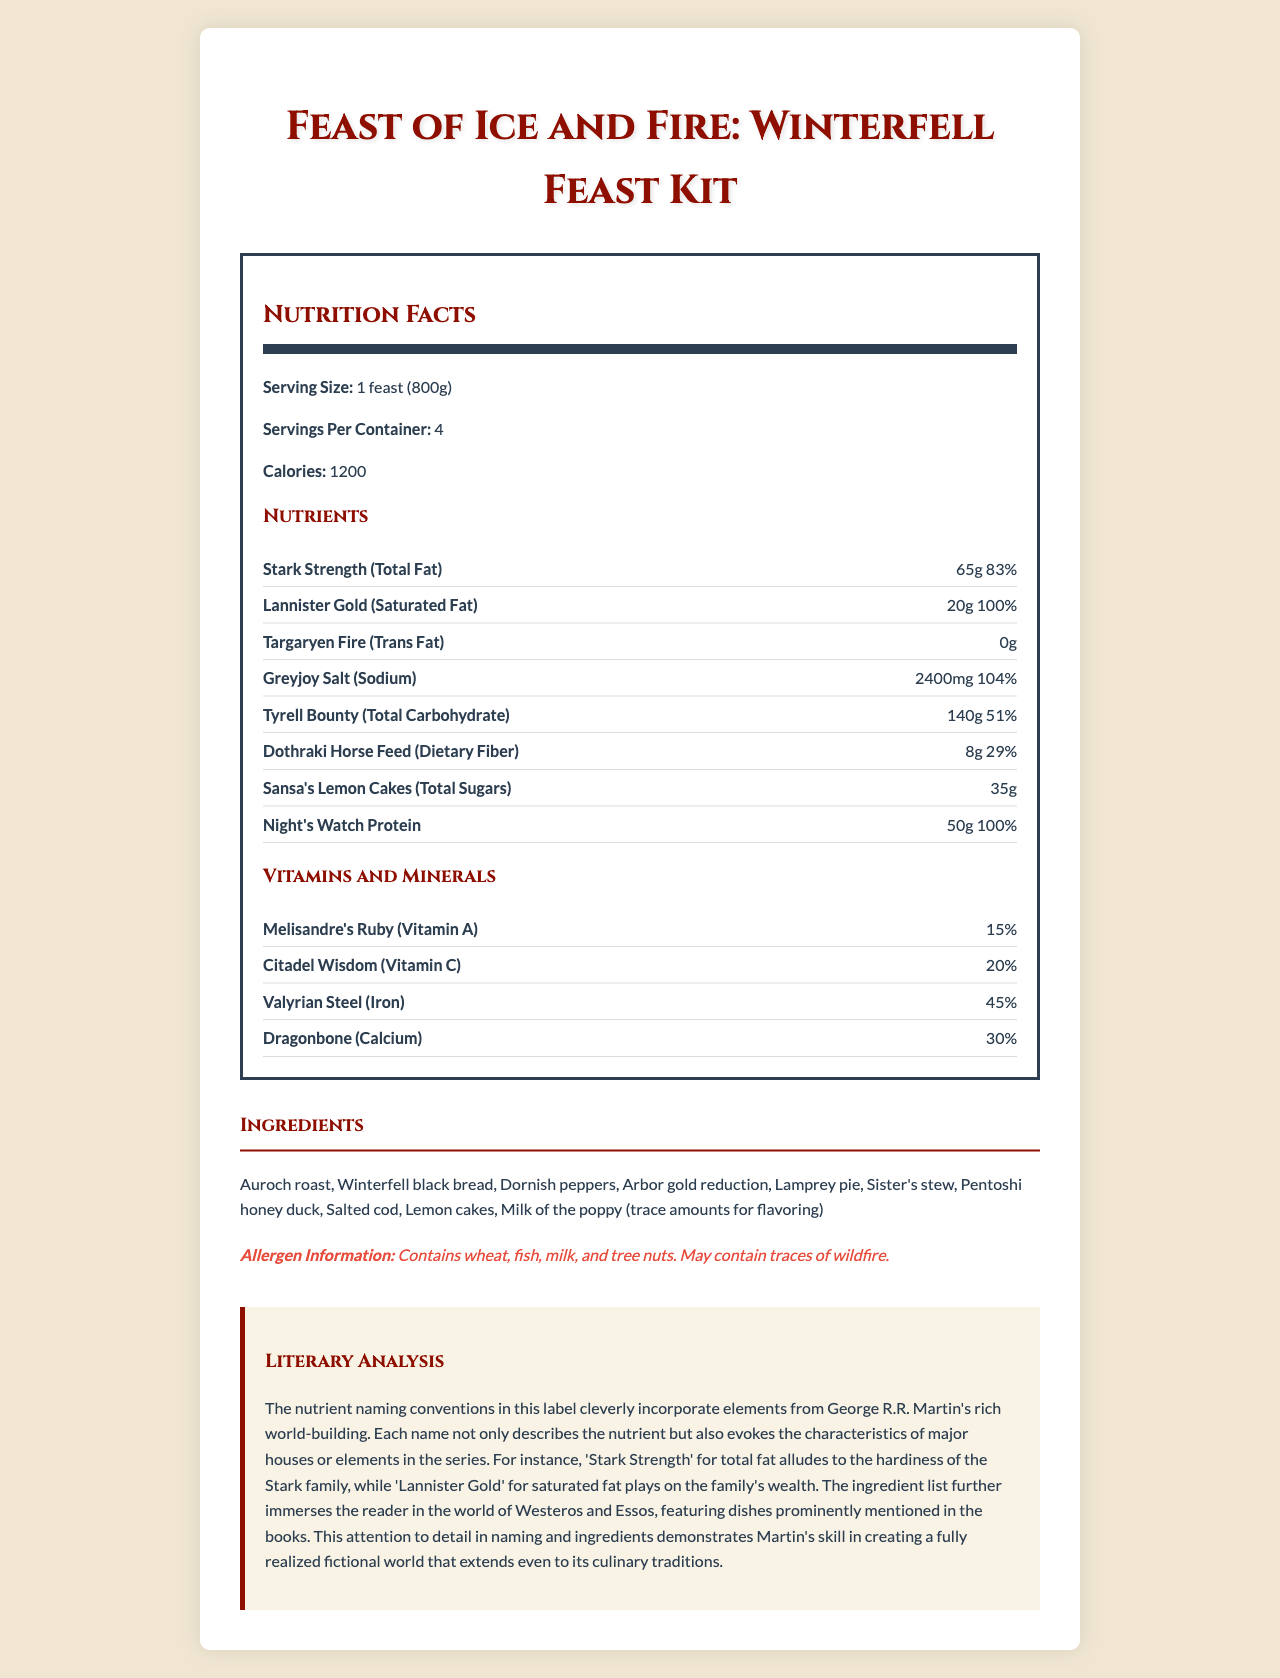what is the serving size for the Feast of Ice and Fire: Winterfell Feast Kit? The serving size is clearly mentioned at the top of the nutrition facts section as "1 feast (800g)."
Answer: 1 feast (800g) how many servings are there per container? The document specifies "Servings Per Container: 4."
Answer: 4 what is the amount of Stark Strength (Total Fat) per serving? The amount of Stark Strength (Total Fat) is listed as 65g in the nutrient section.
Answer: 65g which nutrient represents the total carbohydrate? In the nutrient section, "Tyrell Bounty" is labeled as Total Carbohydrate with an amount of 140g.
Answer: Tyrell Bounty how much protein is in one feast? The document lists "Night's Watch Protein" as having 50g in one feast.
Answer: 50g what is the percentage daily value of Dragonbone (Calcium)? Dragonbone (Calcium) is listed in the vitamins and minerals section with a daily value of 30%.
Answer: 30% does the Feast of Ice and Fire: Winterfell Feast Kit contain any trans fat? A. Yes B. No C. Not mentioned Under "Targaryen Fire (Trans Fat)," the amount is listed as 0g, indicating no trans fat.
Answer: B. No how much sodium is in each serving of the meal kit? A. 1500mg B. 2000mg C. 2400mg D. 3000mg The document lists "Greyjoy Salt (Sodium)" as containing 2400mg per serving.
Answer: C. 2400mg which of the following vitamins is present in the highest daily value percentage? A. Melisandre's Ruby (Vitamin A) B. Citadel Wisdom (Vitamin C) C. Valyrian Steel (Iron) D. Dragonbone (Calcium) The daily values are Vitamin A: 15%, Vitamin C: 20%, Iron: 45%, and Calcium: 30%. Iron has the highest daily value percentage at 45%.
Answer: C. Valyrian Steel (Iron) does the document specify any allergens in the meal kit? The allergen information section notes that the kit contains wheat, fish, milk, and tree nuts.
Answer: Yes describe the main idea of the document. The document provides comprehensive nutritional details for a Game of Thrones-themed meal kit, highlighting the clever naming conventions inspired by the series' fictional universe, along with practical dietary information.
Answer: The document presents the nutritional information for the "Feast of Ice and Fire: Winterfell Feast Kit," featuring nutrients named after elements from the Game of Thrones world, such as Stark Strength for total fat and Tyrell Bounty for total carbohydrate. It includes serving size, calories, nutrients, vitamins and minerals, ingredients, and allergen information, catering to fans of the book series with a creatively themed meal kit. how much Vitamin D is included in the meal kit? The document does not mention Vitamin D in the vitamins and minerals section or anywhere else, so we cannot determine the amount.
Answer: Not enough information 